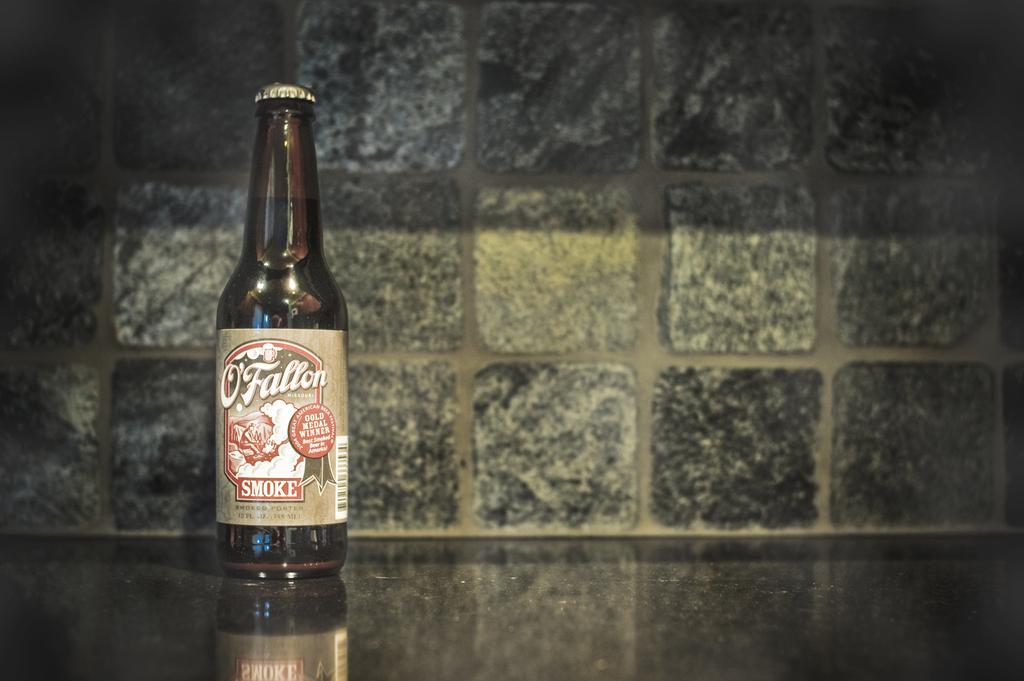What brand of beer is this?
Your response must be concise. O'fallon. 